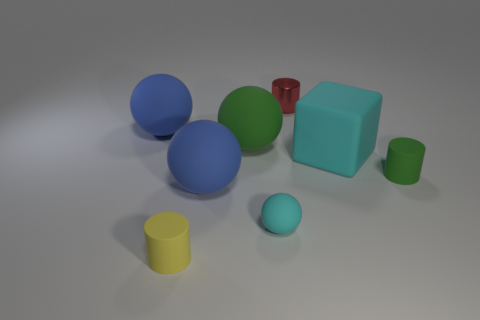How many objects are there in the image, and can you describe their colors and shapes? In the visual composition, we observe a total of seven objects. There are three spheres, with one each in the shades of cyan, blue, and dark blue. Additionally, there are two cylinders, one is yellow and the other green. Two cubes are also present, where one is a large cyan and the other a small red.  Can you compare the sizes of the spheres? Certainly, the spheres exhibit a variety of sizes. The cyan sphere is the smallest, followed by the dark blue sphere which is moderately larger, and the blue sphere holds the largest volume among the trio. 